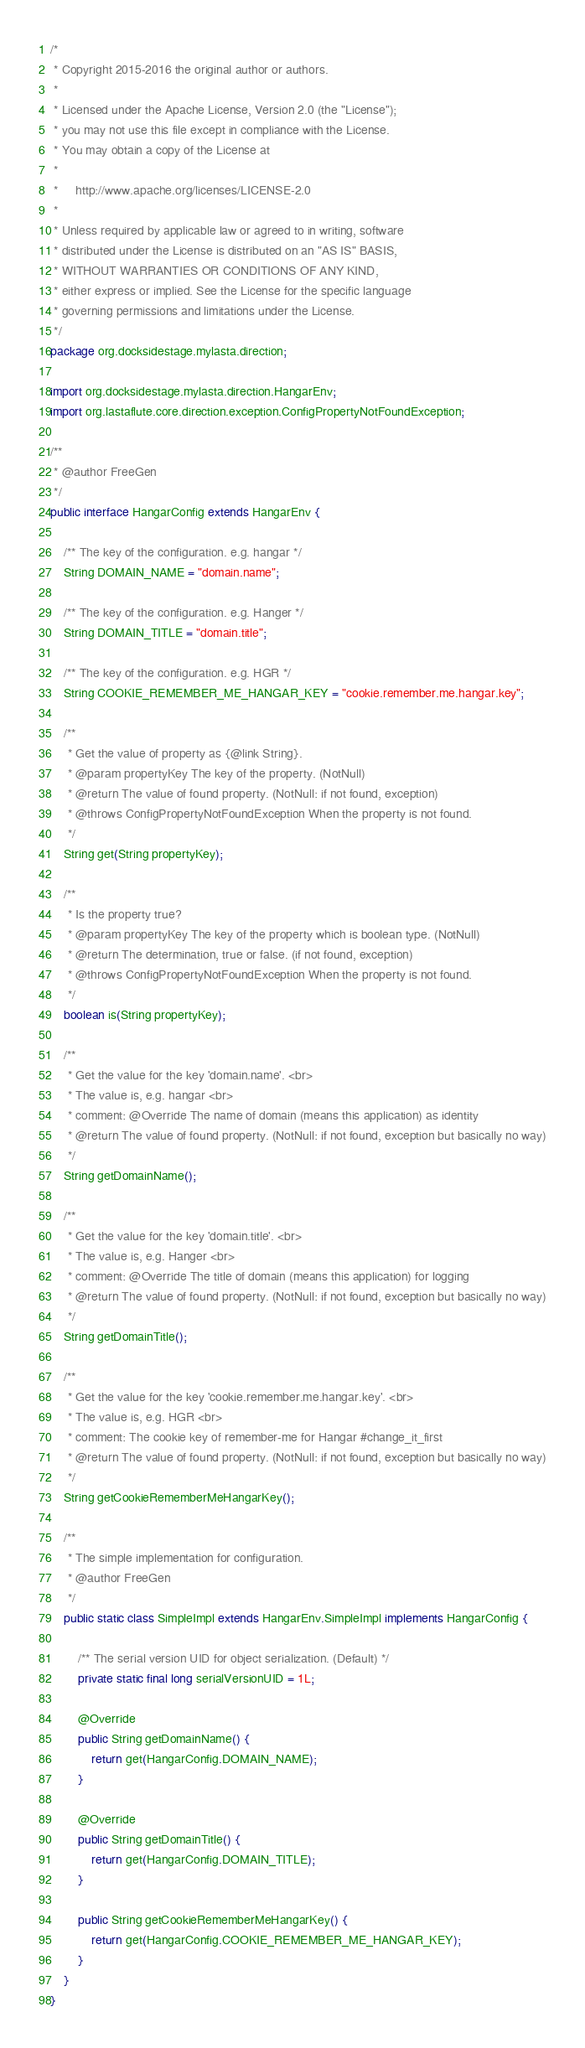<code> <loc_0><loc_0><loc_500><loc_500><_Java_>/*
 * Copyright 2015-2016 the original author or authors.
 *
 * Licensed under the Apache License, Version 2.0 (the "License");
 * you may not use this file except in compliance with the License.
 * You may obtain a copy of the License at
 *
 *     http://www.apache.org/licenses/LICENSE-2.0
 *
 * Unless required by applicable law or agreed to in writing, software
 * distributed under the License is distributed on an "AS IS" BASIS,
 * WITHOUT WARRANTIES OR CONDITIONS OF ANY KIND,
 * either express or implied. See the License for the specific language
 * governing permissions and limitations under the License.
 */
package org.docksidestage.mylasta.direction;

import org.docksidestage.mylasta.direction.HangarEnv;
import org.lastaflute.core.direction.exception.ConfigPropertyNotFoundException;

/**
 * @author FreeGen
 */
public interface HangarConfig extends HangarEnv {

    /** The key of the configuration. e.g. hangar */
    String DOMAIN_NAME = "domain.name";

    /** The key of the configuration. e.g. Hanger */
    String DOMAIN_TITLE = "domain.title";

    /** The key of the configuration. e.g. HGR */
    String COOKIE_REMEMBER_ME_HANGAR_KEY = "cookie.remember.me.hangar.key";

    /**
     * Get the value of property as {@link String}.
     * @param propertyKey The key of the property. (NotNull)
     * @return The value of found property. (NotNull: if not found, exception)
     * @throws ConfigPropertyNotFoundException When the property is not found.
     */
    String get(String propertyKey);

    /**
     * Is the property true?
     * @param propertyKey The key of the property which is boolean type. (NotNull)
     * @return The determination, true or false. (if not found, exception)
     * @throws ConfigPropertyNotFoundException When the property is not found.
     */
    boolean is(String propertyKey);

    /**
     * Get the value for the key 'domain.name'. <br>
     * The value is, e.g. hangar <br>
     * comment: @Override The name of domain (means this application) as identity
     * @return The value of found property. (NotNull: if not found, exception but basically no way)
     */
    String getDomainName();

    /**
     * Get the value for the key 'domain.title'. <br>
     * The value is, e.g. Hanger <br>
     * comment: @Override The title of domain (means this application) for logging
     * @return The value of found property. (NotNull: if not found, exception but basically no way)
     */
    String getDomainTitle();

    /**
     * Get the value for the key 'cookie.remember.me.hangar.key'. <br>
     * The value is, e.g. HGR <br>
     * comment: The cookie key of remember-me for Hangar #change_it_first
     * @return The value of found property. (NotNull: if not found, exception but basically no way)
     */
    String getCookieRememberMeHangarKey();

    /**
     * The simple implementation for configuration.
     * @author FreeGen
     */
    public static class SimpleImpl extends HangarEnv.SimpleImpl implements HangarConfig {

        /** The serial version UID for object serialization. (Default) */
        private static final long serialVersionUID = 1L;

        @Override
        public String getDomainName() {
            return get(HangarConfig.DOMAIN_NAME);
        }

        @Override
        public String getDomainTitle() {
            return get(HangarConfig.DOMAIN_TITLE);
        }

        public String getCookieRememberMeHangarKey() {
            return get(HangarConfig.COOKIE_REMEMBER_ME_HANGAR_KEY);
        }
    }
}
</code> 